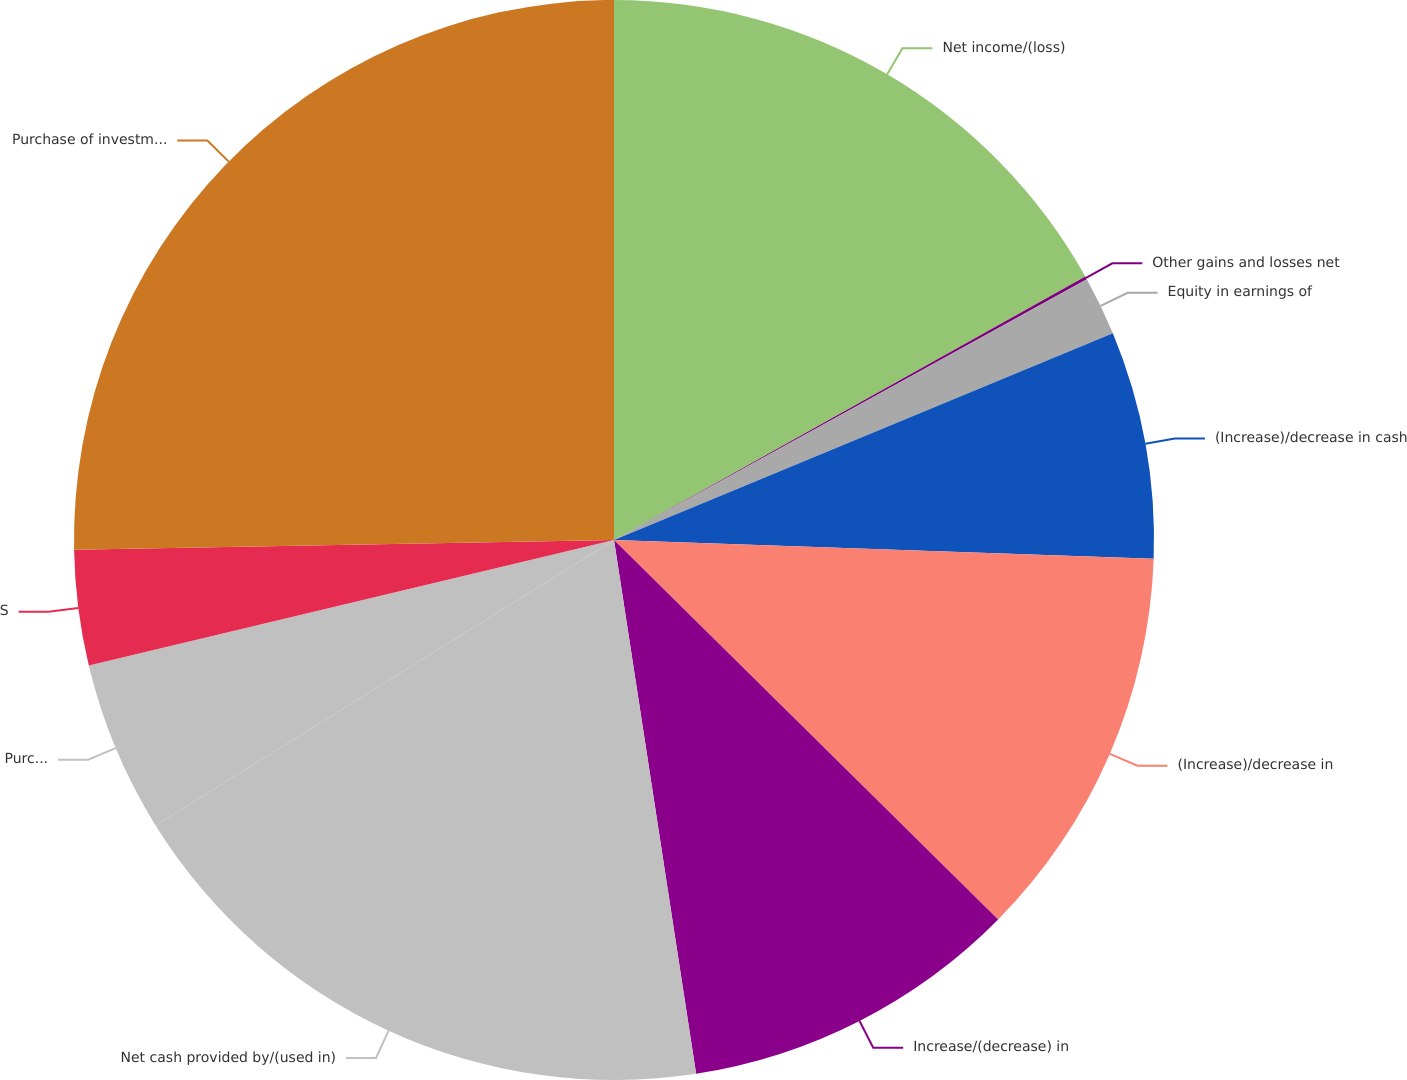<chart> <loc_0><loc_0><loc_500><loc_500><pie_chart><fcel>Net income/(loss)<fcel>Other gains and losses net<fcel>Equity in earnings of<fcel>(Increase)/decrease in cash<fcel>(Increase)/decrease in<fcel>Increase/(decrease) in<fcel>Net cash provided by/(used in)<fcel>Purchase of available-for-sale<fcel>Sale of available-for-sale<fcel>Purchase of investments by CIP<nl><fcel>16.89%<fcel>0.09%<fcel>1.77%<fcel>6.81%<fcel>11.85%<fcel>10.17%<fcel>18.57%<fcel>5.13%<fcel>3.45%<fcel>25.29%<nl></chart> 